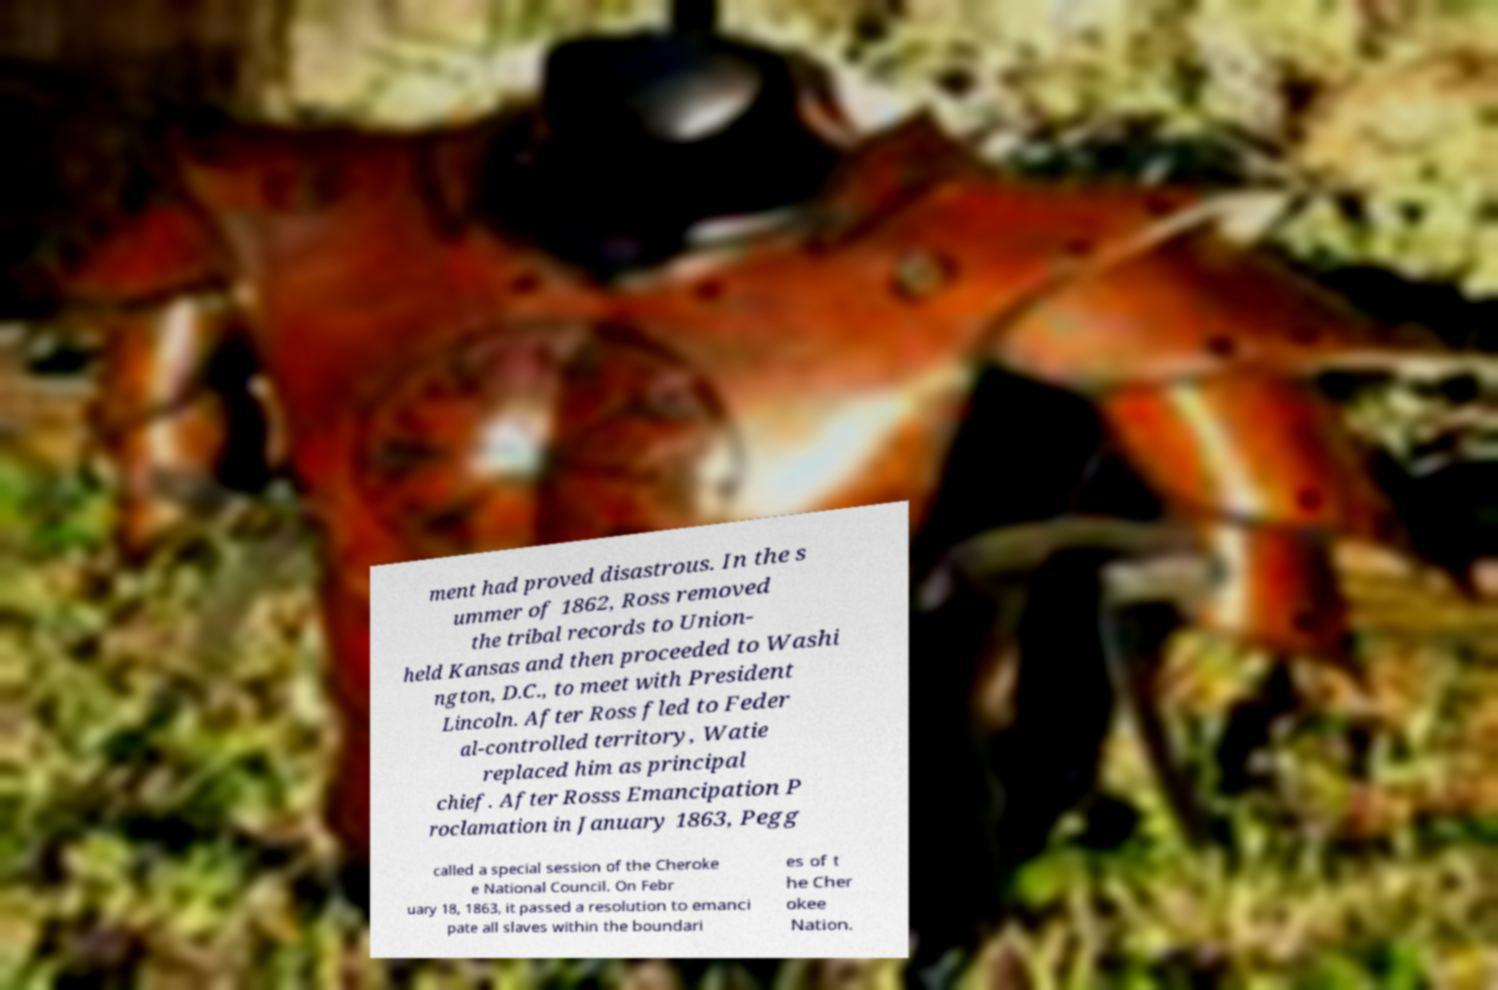For documentation purposes, I need the text within this image transcribed. Could you provide that? ment had proved disastrous. In the s ummer of 1862, Ross removed the tribal records to Union- held Kansas and then proceeded to Washi ngton, D.C., to meet with President Lincoln. After Ross fled to Feder al-controlled territory, Watie replaced him as principal chief. After Rosss Emancipation P roclamation in January 1863, Pegg called a special session of the Cheroke e National Council. On Febr uary 18, 1863, it passed a resolution to emanci pate all slaves within the boundari es of t he Cher okee Nation. 